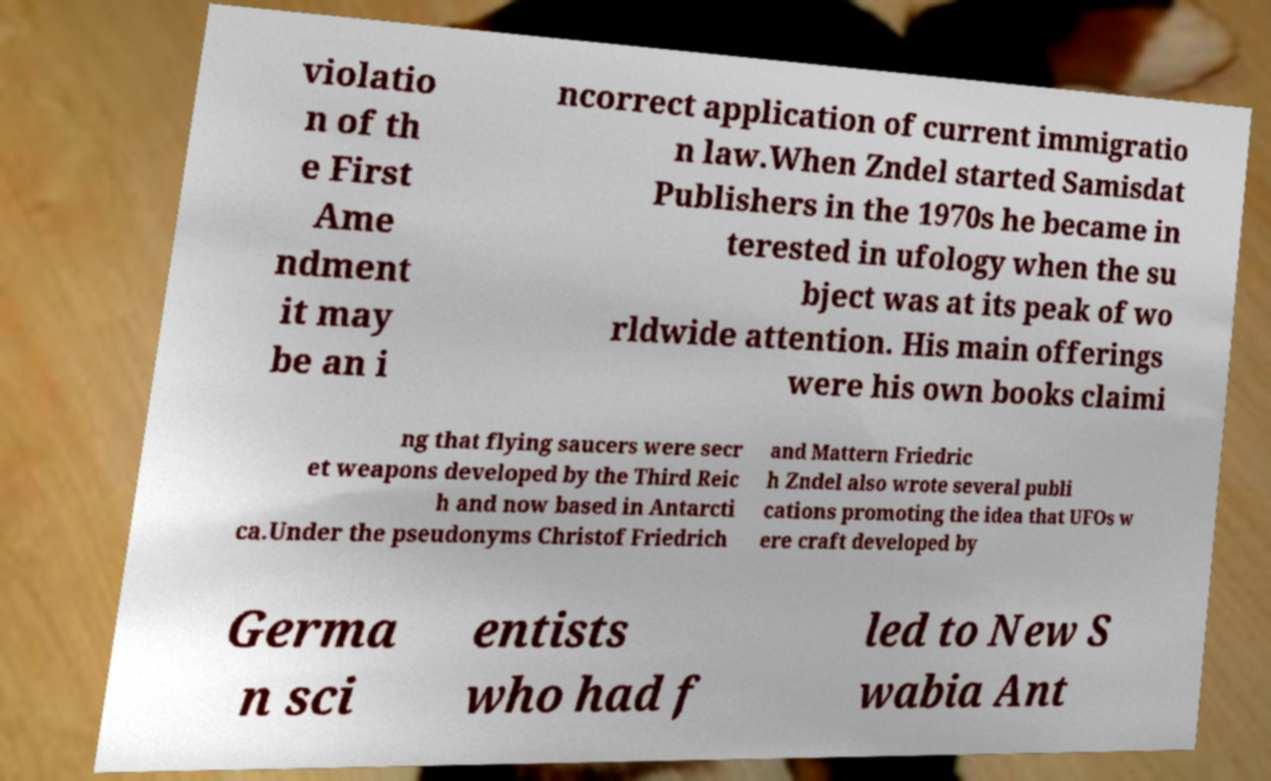Could you extract and type out the text from this image? violatio n of th e First Ame ndment it may be an i ncorrect application of current immigratio n law.When Zndel started Samisdat Publishers in the 1970s he became in terested in ufology when the su bject was at its peak of wo rldwide attention. His main offerings were his own books claimi ng that flying saucers were secr et weapons developed by the Third Reic h and now based in Antarcti ca.Under the pseudonyms Christof Friedrich and Mattern Friedric h Zndel also wrote several publi cations promoting the idea that UFOs w ere craft developed by Germa n sci entists who had f led to New S wabia Ant 